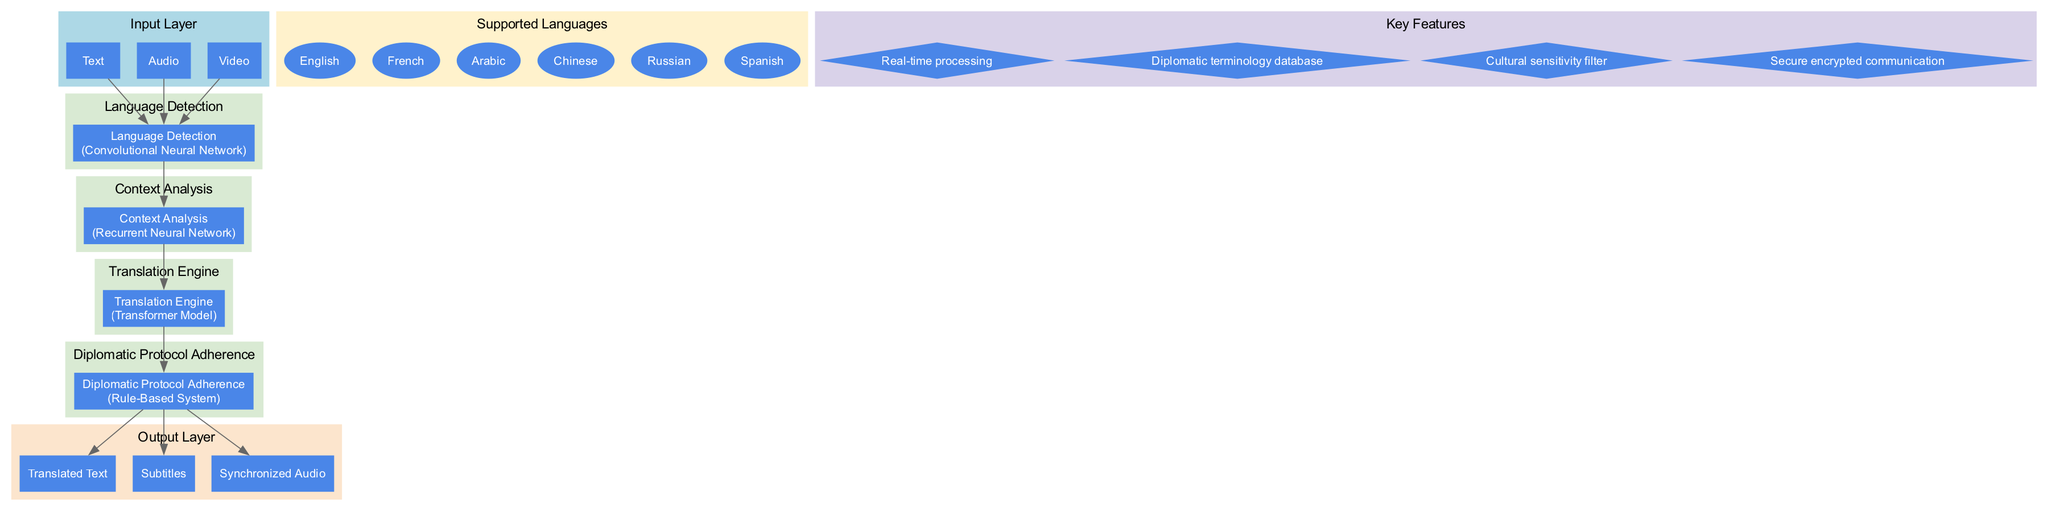What is the name of the input layer? The input layer is labeled as "Diplomatic Communication Input" according to the diagram's structure.
Answer: Diplomatic Communication Input How many processing layers are present in the diagram? The diagram displays a total of four processing layers: Language Detection, Context Analysis, Translation Engine, and Diplomatic Protocol Adherence.
Answer: 4 What type of model is used in the Translation Engine? The Translation Engine is categorized under the Transformer Model type, as specified in the processing layers of the diagram.
Answer: Transformer Model What elements are included in the output layer? The output layer contains three elements: Translated Text, Subtitles, and Synchronized Audio, which directly represent the outcomes of the processing stages.
Answer: Translated Text, Subtitles, Synchronized Audio Which processing layer involves context analysis? The processing layer titled "Context Analysis" explicitly indicates that it focuses on analyzing the context of communications to aid translation.
Answer: Context Analysis How do the processing layers connect to each other? The diagram shows directed edges connecting each processing layer in sequence, indicating flow from Language Detection to Context Analysis, then to the Translation Engine, and finally to Diplomatic Protocol Adherence.
Answer: Sequentially What is the purpose of the Rule-Based System in the architecture? The Rule-Based System ensures adherence to diplomatic protocols, indicating its role in maintaining formal communication standards during translation.
Answer: Adherence to diplomatic protocols How many languages are supported according to the diagram? The diagram lists six supported languages: English, French, Arabic, Chinese, Russian, and Spanish, confirming the diverse linguistic capabilities of the system.
Answer: 6 What is one of the key features of this machine learning architecture? One key feature of this architecture is "Real-time processing," highlighting its ability to provide immediate translation of communications.
Answer: Real-time processing 